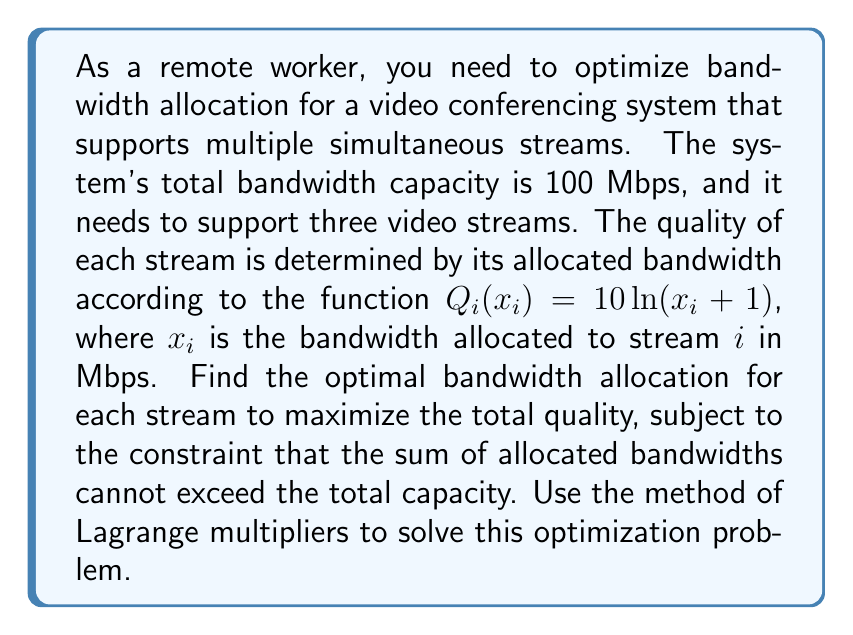What is the answer to this math problem? To solve this problem, we'll use the method of Lagrange multipliers:

1) Define the objective function:
   $f(x_1, x_2, x_3) = Q_1(x_1) + Q_2(x_2) + Q_3(x_3) = 10\ln(x_1 + 1) + 10\ln(x_2 + 1) + 10\ln(x_3 + 1)$

2) Define the constraint:
   $g(x_1, x_2, x_3) = x_1 + x_2 + x_3 - 100 = 0$

3) Form the Lagrangian:
   $L(x_1, x_2, x_3, \lambda) = f(x_1, x_2, x_3) - \lambda g(x_1, x_2, x_3)$
   $L(x_1, x_2, x_3, \lambda) = 10\ln(x_1 + 1) + 10\ln(x_2 + 1) + 10\ln(x_3 + 1) - \lambda(x_1 + x_2 + x_3 - 100)$

4) Take partial derivatives and set them equal to zero:
   $\frac{\partial L}{\partial x_1} = \frac{10}{x_1 + 1} - \lambda = 0$
   $\frac{\partial L}{\partial x_2} = \frac{10}{x_2 + 1} - \lambda = 0$
   $\frac{\partial L}{\partial x_3} = \frac{10}{x_3 + 1} - \lambda = 0$
   $\frac{\partial L}{\partial \lambda} = x_1 + x_2 + x_3 - 100 = 0$

5) From the first three equations, we can conclude:
   $\frac{10}{x_1 + 1} = \frac{10}{x_2 + 1} = \frac{10}{x_3 + 1} = \lambda$

   This implies $x_1 = x_2 = x_3$

6) Let $x = x_1 = x_2 = x_3$. From the constraint equation:
   $x + x + x = 100$
   $3x = 100$
   $x = \frac{100}{3} \approx 33.33$

Therefore, the optimal bandwidth allocation is approximately 33.33 Mbps for each of the three streams.
Answer: $x_1 = x_2 = x_3 \approx 33.33$ Mbps 